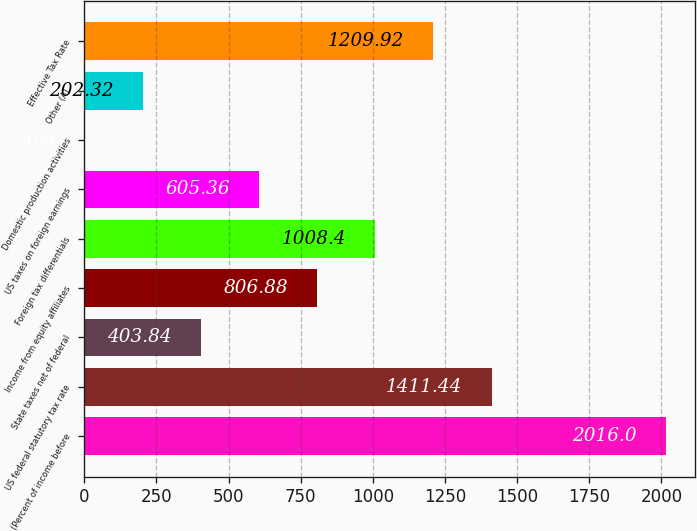Convert chart to OTSL. <chart><loc_0><loc_0><loc_500><loc_500><bar_chart><fcel>(Percent of income before<fcel>US federal statutory tax rate<fcel>State taxes net of federal<fcel>Income from equity affiliates<fcel>Foreign tax differentials<fcel>US taxes on foreign earnings<fcel>Domestic production activities<fcel>Other (A)<fcel>Effective Tax Rate<nl><fcel>2016<fcel>1411.44<fcel>403.84<fcel>806.88<fcel>1008.4<fcel>605.36<fcel>0.8<fcel>202.32<fcel>1209.92<nl></chart> 